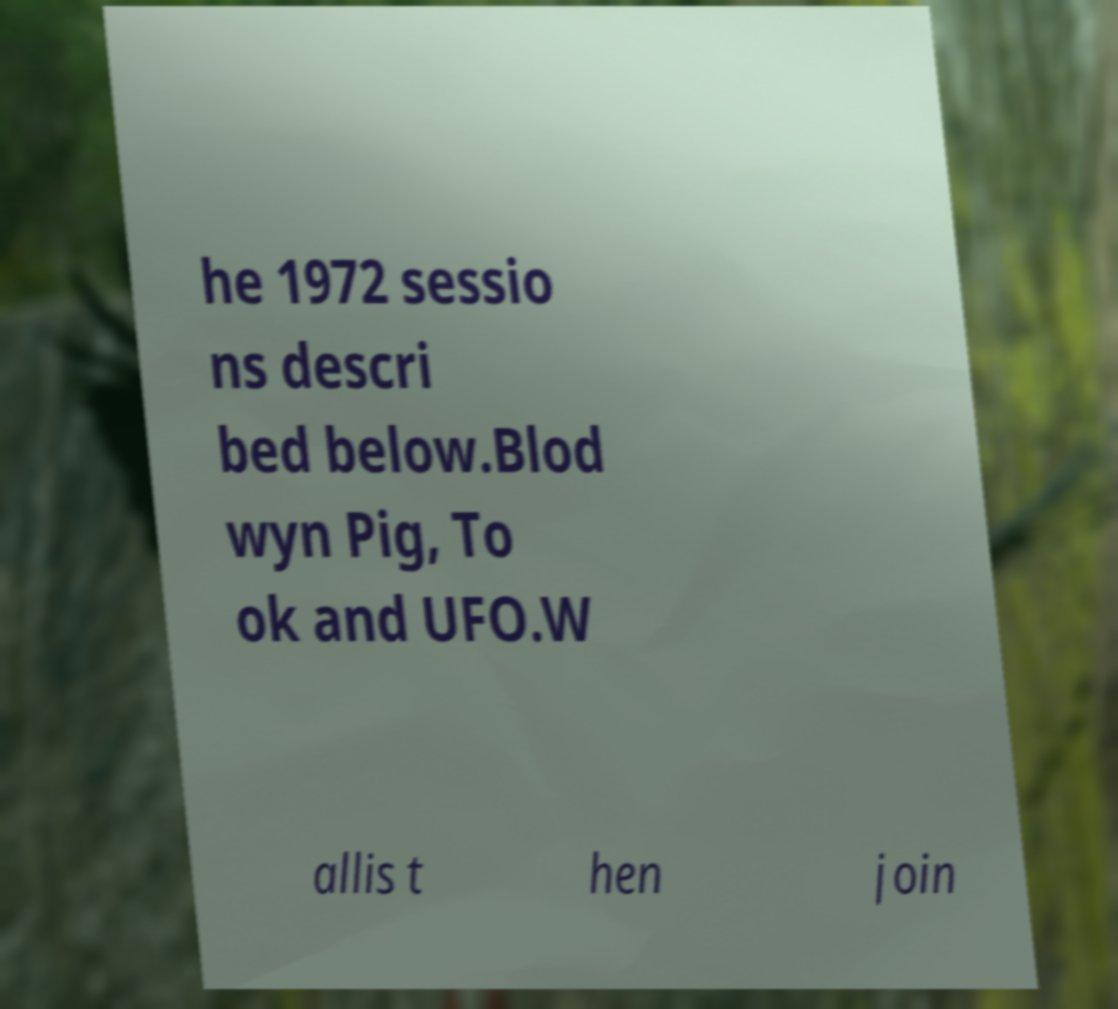For documentation purposes, I need the text within this image transcribed. Could you provide that? he 1972 sessio ns descri bed below.Blod wyn Pig, To ok and UFO.W allis t hen join 